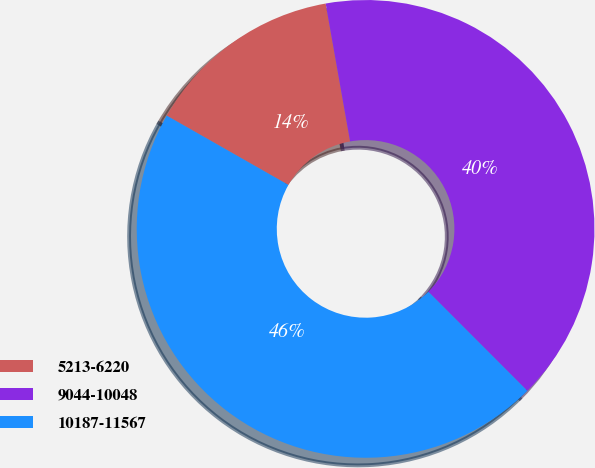<chart> <loc_0><loc_0><loc_500><loc_500><pie_chart><fcel>5213-6220<fcel>9044-10048<fcel>10187-11567<nl><fcel>13.97%<fcel>40.3%<fcel>45.73%<nl></chart> 